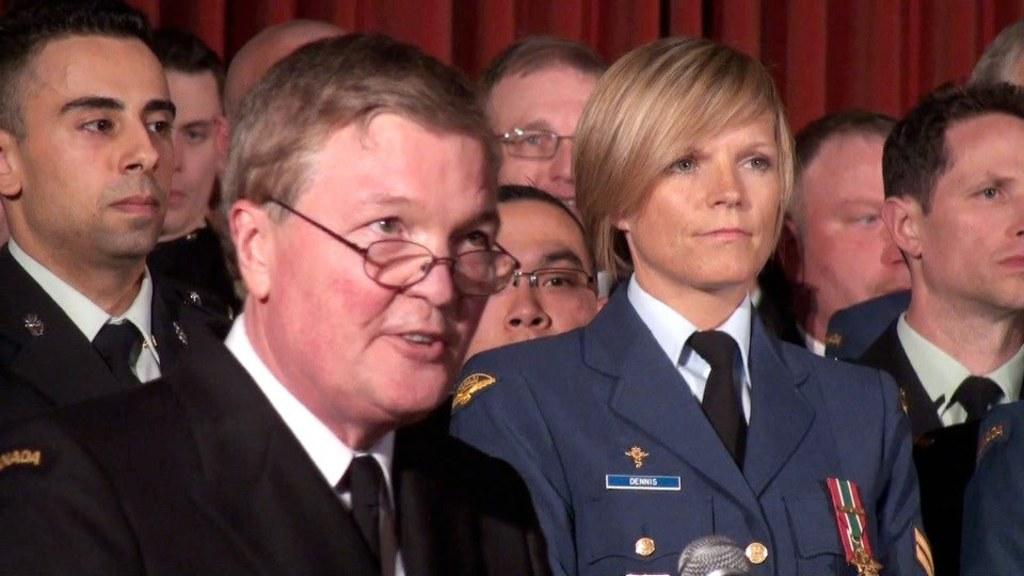How many people are in the image? There is a group of people in the image, but the exact number is not specified. What are the people in the image doing? The people are standing in the image. What object is located at the bottom of the image? There is a microphone at the bottom of the image. What can be seen in the background of the image? There is a curtain in the background of the image. What type of jar is being used to store the tomatoes in the image? There is no jar or tomatoes present in the image. What kind of system is being used to organize the people in the image? There is no system for organizing the people in the image; they are simply standing. 